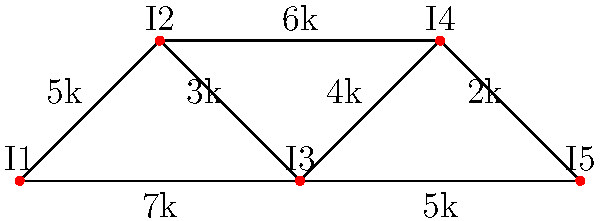You're planning an influencer marketing campaign for a client. The graph represents five influencers (I1 to I5) and their follower overlaps (in thousands). What's the minimum number of influencers you need to reach at least 15,000 unique followers? To solve this problem, we need to find the maximum coverage with the minimum number of influencers. Let's approach this step-by-step:

1) First, we need to calculate the total reach for each influencer:
   I1: 5k + 7k = 12k
   I2: 5k + 3k + 6k = 14k
   I3: 7k + 3k + 4k + 5k = 19k
   I4: 6k + 4k + 2k = 12k
   I5: 5k + 2k = 7k

2) We see that I3 has the highest reach at 19k, which already exceeds our target of 15k.

3) Therefore, we only need to select I3 to reach our goal.

4) We can verify that selecting any other single influencer or any combination of two influencers (other than those including I3) would not reach the 15k target.

Thus, the minimum number of influencers needed to reach at least 15,000 unique followers is 1, by selecting influencer I3.
Answer: 1 